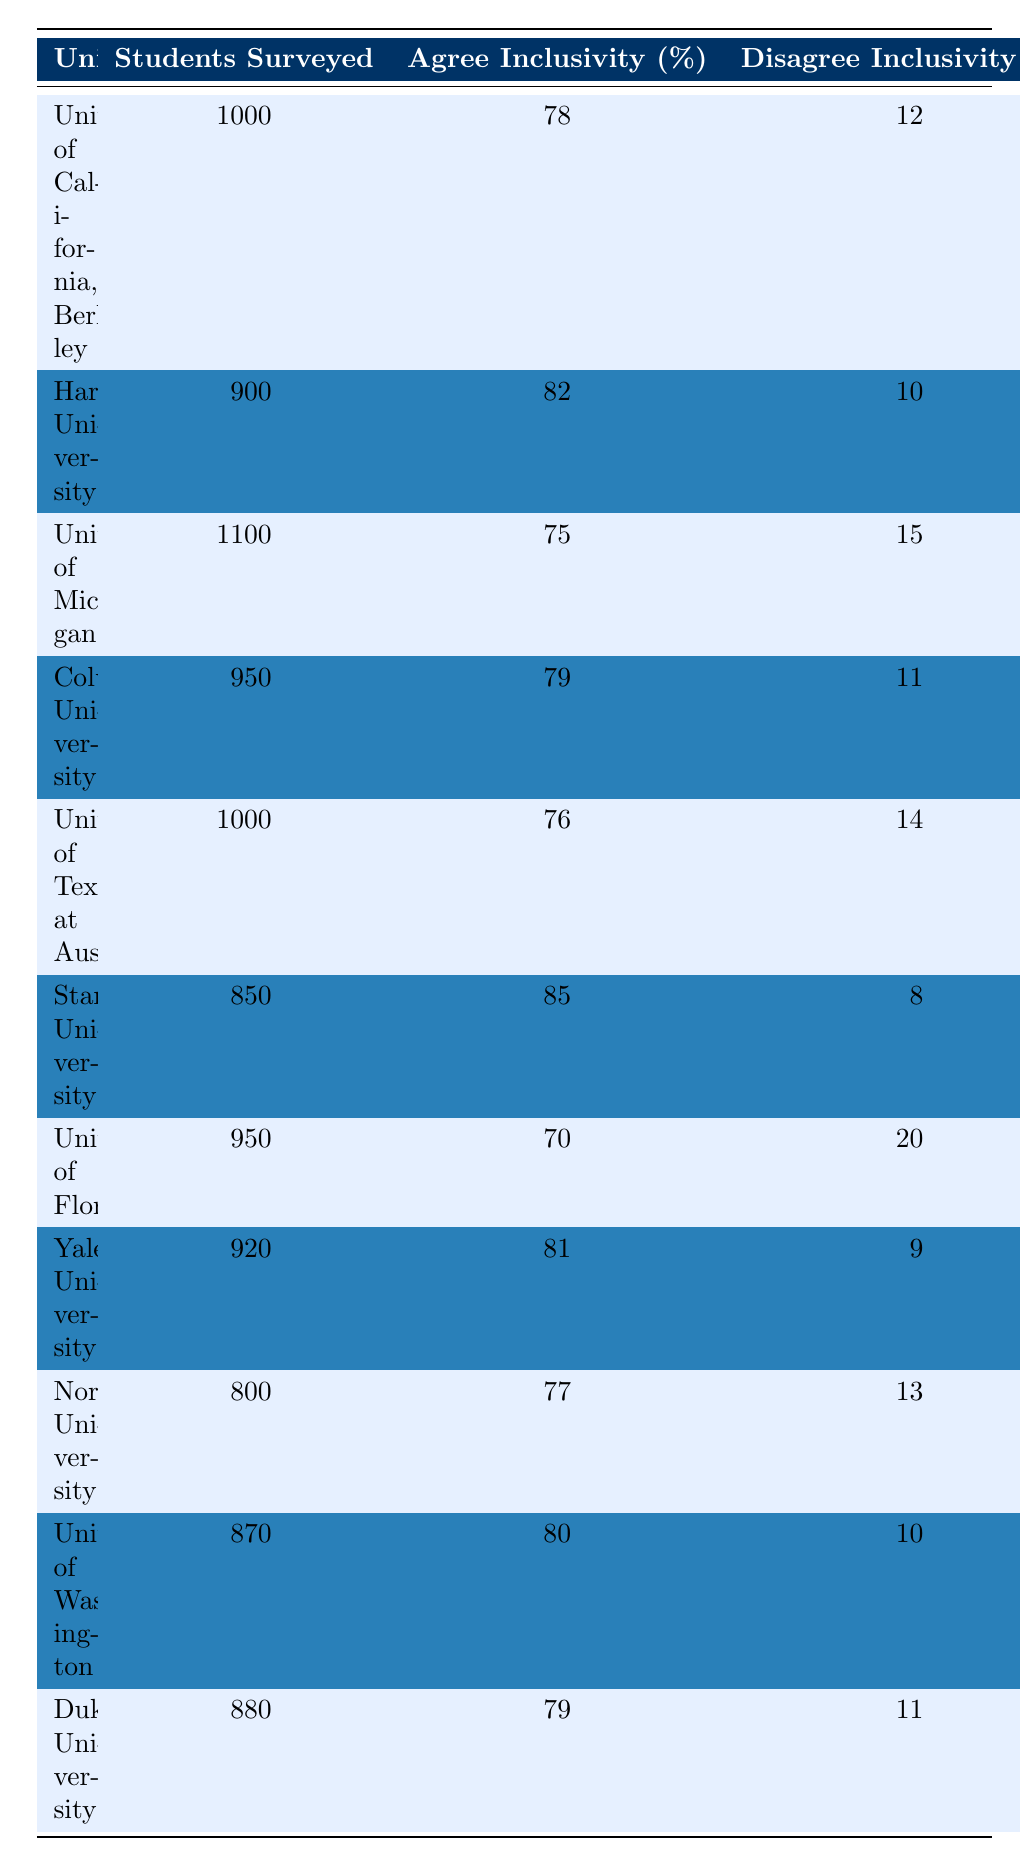What percentage of students at Stanford University agree with inclusivity? The table shows that 85% of students at Stanford University agree with inclusivity.
Answer: 85% Which university had the highest percentage of students supporting diversity programs? Yale University had the highest percentage of students supporting diversity programs at 91%.
Answer: 91% What is the average percentage of students across all universities who agree with inclusivity? The percentages of agreement for inclusivity are 78, 82, 75, 79, 76, 85, 70, 81, 77, and 79. Adding them gives 782. Dividing by 10 (the number of universities) gives an average of 78.2%.
Answer: 78.2% Did the majority of students at the University of Florida express concern about extremism? The table indicates that 78% of students at the University of Florida expressed concern about extremism, which is a majority.
Answer: Yes How many universities have less than 75% of students agreeing with inclusivity? By checking the table, only two universities (University of Michigan at 75% and University of Florida at 70%) have less than 75%, thus the total is 2.
Answer: 2 What is the difference in percentage between students at Harvard and Yale who are not concerned about extremism? Harvard has 20% of students not concerned about extremism, while Yale has 30%. The difference is 30% - 20% = 10%.
Answer: 10% Which universities have over 80% support for diversity programs? Columbia University (90%), Yale University (91%), and Stanford University (87%) have over 80% support for diversity programs.
Answer: Columbia, Yale, Stanford What is the median percentage of students agreeing with inclusivity among the universities surveyed? First, we arrange the percentages: 70, 75, 76, 77, 78, 79, 79, 81, 82, 85. The median (the middle value) is then the average of the 5th and 6th values: (78 + 79)/2 = 78.5%.
Answer: 78.5% Is it true that the majority of students at Northwestern University feel concerned about extremism? The table shows that 66% of students at Northwestern University are concerned about extremism, which is indeed a majority.
Answer: Yes Which university exhibited the lowest level of agreement with inclusivity, and what was the percentage? The University of Florida had the lowest level of agreement with inclusivity at 70%.
Answer: University of Florida, 70% 